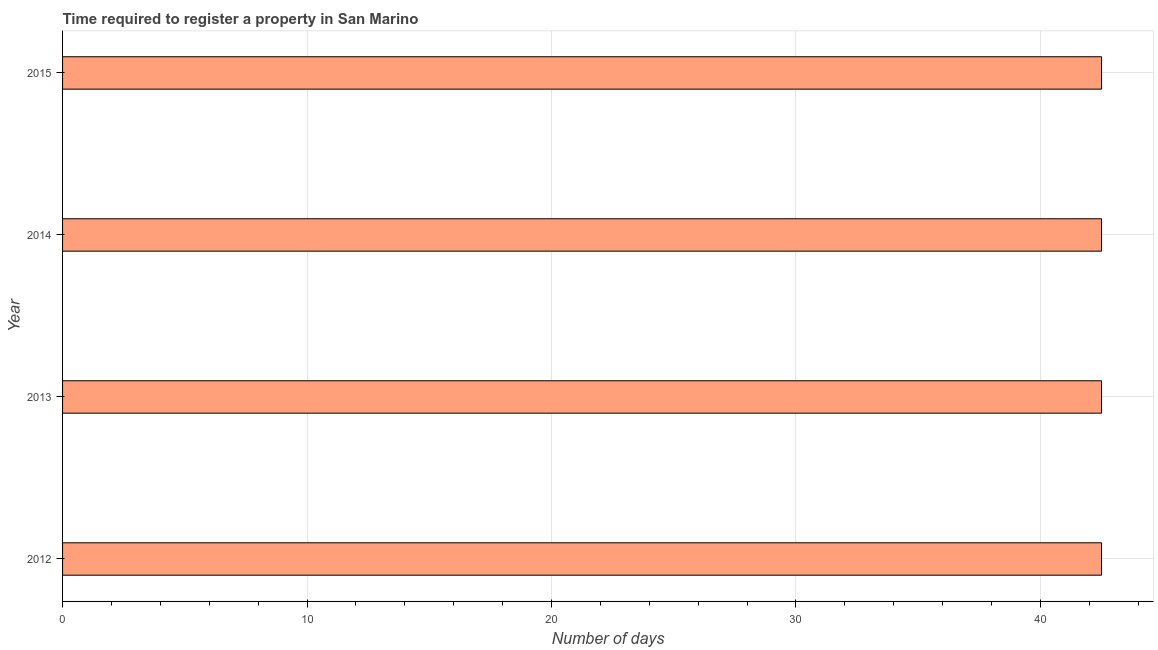Does the graph contain any zero values?
Keep it short and to the point. No. Does the graph contain grids?
Ensure brevity in your answer.  Yes. What is the title of the graph?
Offer a terse response. Time required to register a property in San Marino. What is the label or title of the X-axis?
Ensure brevity in your answer.  Number of days. What is the label or title of the Y-axis?
Keep it short and to the point. Year. What is the number of days required to register property in 2012?
Your answer should be compact. 42.5. Across all years, what is the maximum number of days required to register property?
Provide a short and direct response. 42.5. Across all years, what is the minimum number of days required to register property?
Keep it short and to the point. 42.5. In which year was the number of days required to register property maximum?
Offer a very short reply. 2012. What is the sum of the number of days required to register property?
Provide a succinct answer. 170. What is the difference between the number of days required to register property in 2013 and 2015?
Keep it short and to the point. 0. What is the average number of days required to register property per year?
Give a very brief answer. 42.5. What is the median number of days required to register property?
Give a very brief answer. 42.5. In how many years, is the number of days required to register property greater than 24 days?
Your answer should be compact. 4. Is the number of days required to register property in 2013 less than that in 2014?
Your response must be concise. No. Is the difference between the number of days required to register property in 2012 and 2013 greater than the difference between any two years?
Offer a very short reply. Yes. Is the sum of the number of days required to register property in 2012 and 2014 greater than the maximum number of days required to register property across all years?
Give a very brief answer. Yes. What is the difference between the highest and the lowest number of days required to register property?
Provide a short and direct response. 0. In how many years, is the number of days required to register property greater than the average number of days required to register property taken over all years?
Your response must be concise. 0. Are all the bars in the graph horizontal?
Your answer should be very brief. Yes. What is the Number of days of 2012?
Keep it short and to the point. 42.5. What is the Number of days in 2013?
Keep it short and to the point. 42.5. What is the Number of days in 2014?
Your response must be concise. 42.5. What is the Number of days of 2015?
Your answer should be very brief. 42.5. What is the difference between the Number of days in 2013 and 2015?
Your response must be concise. 0. What is the ratio of the Number of days in 2012 to that in 2014?
Your response must be concise. 1. What is the ratio of the Number of days in 2012 to that in 2015?
Your response must be concise. 1. What is the ratio of the Number of days in 2014 to that in 2015?
Your answer should be compact. 1. 